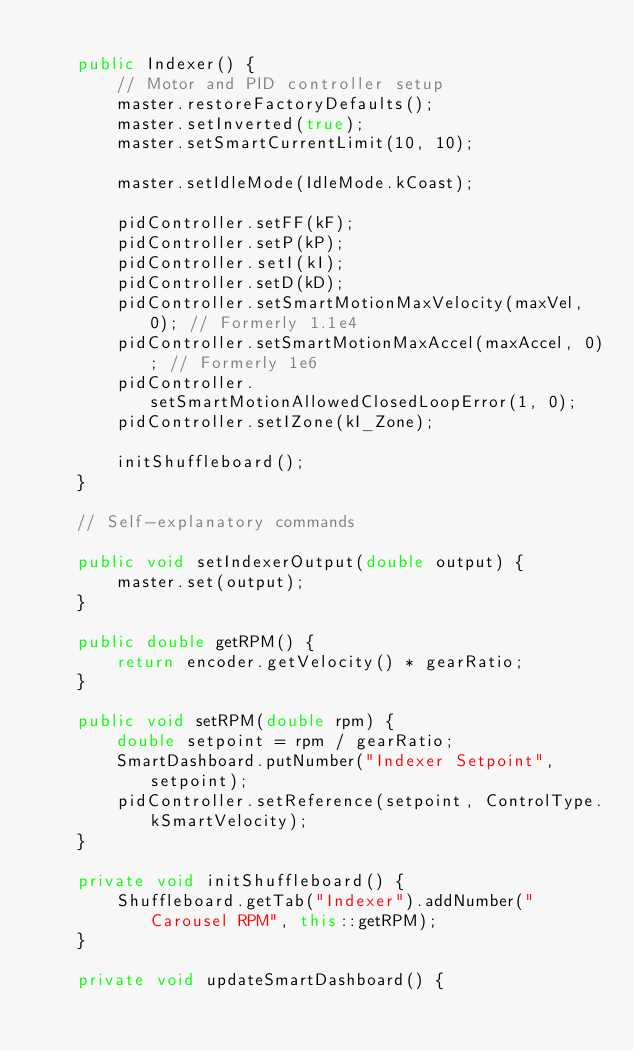Convert code to text. <code><loc_0><loc_0><loc_500><loc_500><_Java_>
    public Indexer() {
        // Motor and PID controller setup
        master.restoreFactoryDefaults();
        master.setInverted(true);
        master.setSmartCurrentLimit(10, 10);

        master.setIdleMode(IdleMode.kCoast);

        pidController.setFF(kF);
        pidController.setP(kP);
        pidController.setI(kI);
        pidController.setD(kD);
        pidController.setSmartMotionMaxVelocity(maxVel, 0); // Formerly 1.1e4
        pidController.setSmartMotionMaxAccel(maxAccel, 0); // Formerly 1e6
        pidController.setSmartMotionAllowedClosedLoopError(1, 0);
        pidController.setIZone(kI_Zone);

        initShuffleboard();
    }

    // Self-explanatory commands

    public void setIndexerOutput(double output) {
        master.set(output);
    }

    public double getRPM() {
        return encoder.getVelocity() * gearRatio;
    }

    public void setRPM(double rpm) {
        double setpoint = rpm / gearRatio;
        SmartDashboard.putNumber("Indexer Setpoint", setpoint);
        pidController.setReference(setpoint, ControlType.kSmartVelocity);
    }

    private void initShuffleboard() {
        Shuffleboard.getTab("Indexer").addNumber("Carousel RPM", this::getRPM);
    }

    private void updateSmartDashboard() {</code> 